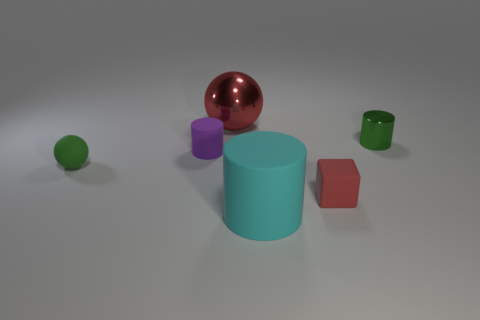Is the small matte cube the same color as the large metallic sphere?
Your answer should be compact. Yes. Are there any other things that are the same shape as the small red thing?
Offer a terse response. No. What number of big things are either rubber cylinders or cyan metallic cubes?
Provide a succinct answer. 1. The small ball is what color?
Ensure brevity in your answer.  Green. There is a green object on the right side of the red thing that is in front of the large red shiny thing; what is its shape?
Offer a very short reply. Cylinder. Are there any big purple objects made of the same material as the small red thing?
Make the answer very short. No. Is the size of the matte cylinder that is in front of the green matte thing the same as the green rubber thing?
Your answer should be very brief. No. How many red objects are metal cylinders or blocks?
Keep it short and to the point. 1. What material is the cylinder that is on the left side of the large matte object?
Your response must be concise. Rubber. There is a big object that is in front of the small purple thing; what number of tiny green objects are right of it?
Provide a short and direct response. 1. 